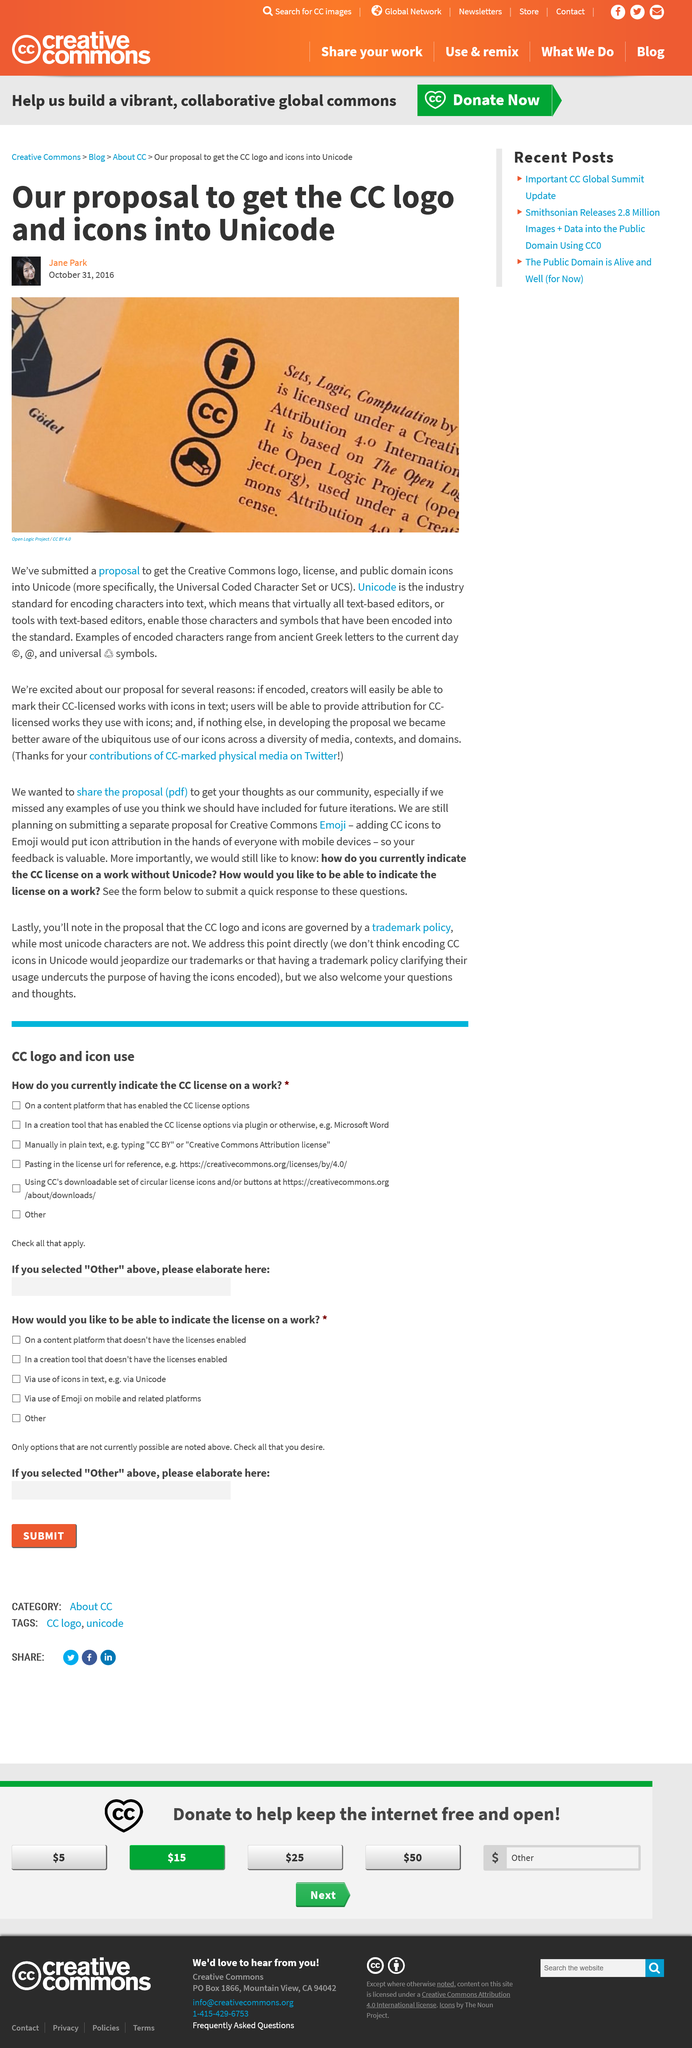Point out several critical features in this image. The Unicode Standard CC proposal includes icons for logo, license, and public domain. It is declared that CC submitted a proposal to incorporate the CC logo into Unicode. Unicode is a standard for encoding characters into text, and is widely used in the industry. 